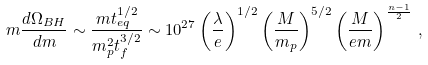<formula> <loc_0><loc_0><loc_500><loc_500>m { \frac { d \Omega _ { B H } } { d m } } \sim { \frac { m t _ { e q } ^ { 1 / 2 } } { m _ { p } ^ { 2 } t _ { f } ^ { 3 / 2 } } } \sim 1 0 ^ { 2 7 } \left ( { \frac { \lambda } { e } } \right ) ^ { 1 / 2 } \left ( { \frac { M } { m _ { p } } } \right ) ^ { 5 / 2 } \left ( { \frac { M } { e m } } \right ) ^ { \frac { n - 1 } { 2 } } \, ,</formula> 